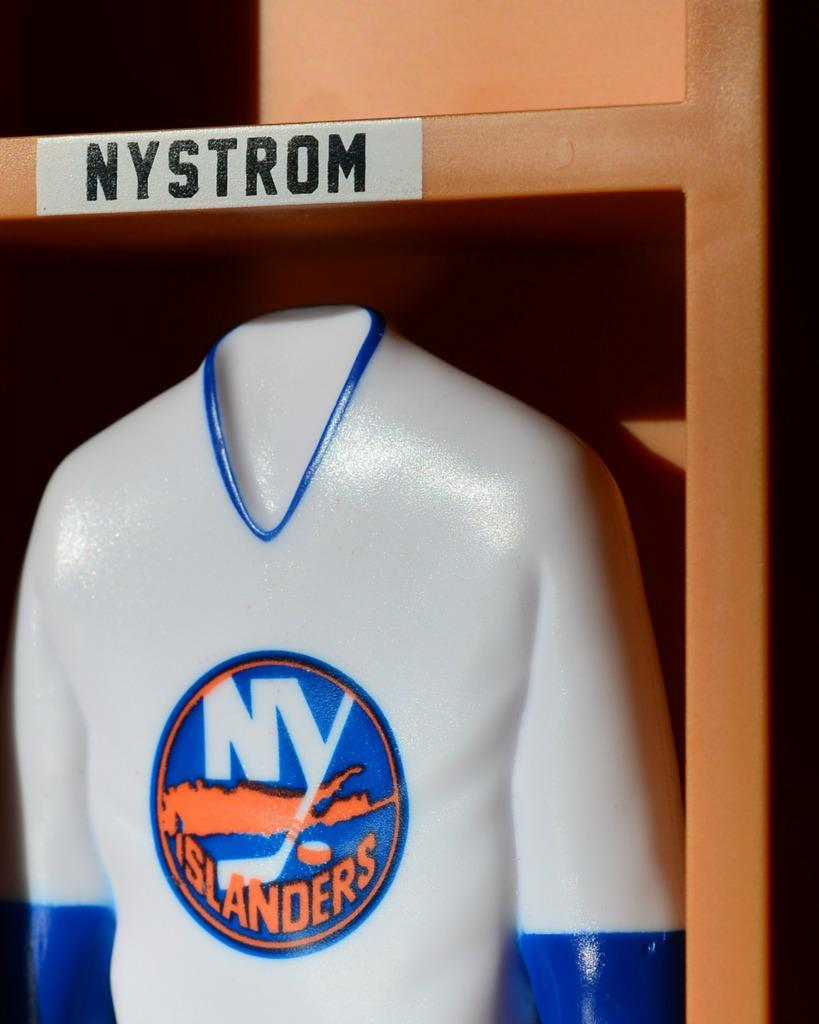<image>
Write a terse but informative summary of the picture. A blue and white New York Islanders uniform is displayed under the name Nystrom. 